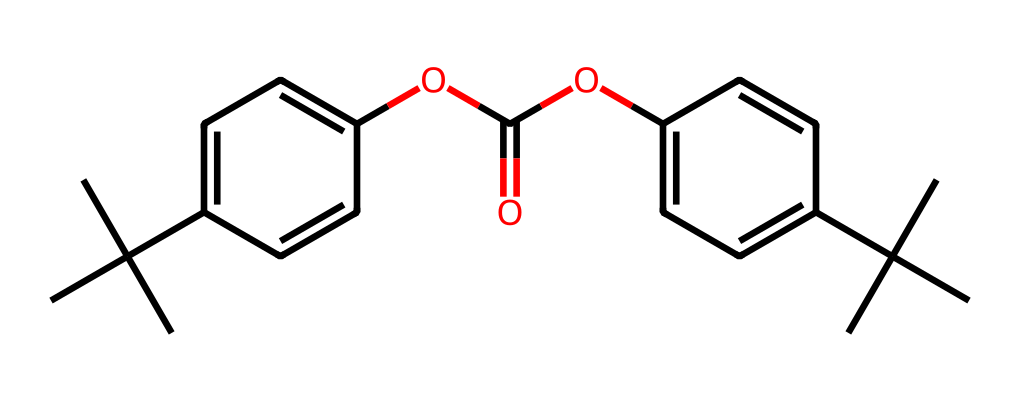How many carbon atoms are present in the molecular structure? By analyzing the SMILES representation, we can count the carbon (C) within the text. Each "C" represents a carbon atom. In this structure, there are various branching and aromatic groups that add up the count of carbon atoms distinctly. Counting all the indicated carbons gives a total of 22 carbon atoms.
Answer: 22 What type of functional group is present in this structure? From the SMILES notation, we can identify the ester functional group by noticing the "OC(=O)" section. The carbon atom (C) is double-bonded to an oxygen atom (O), and also bonded to another functional group or structure, indicating it's an ester.
Answer: ester What is the primary application of polycarbonate plastic? Polycarbonate plastic is primarily used in applications where strength, transparency, and impact resistance are required. This includes products like DVDs and Blu-ray discs, where its properties are essential for durability and clarity.
Answer: DVDs and Blu-rays Does this structure indicate any aromatic rings? By examining the molecular structure derived from the SMILES representation, we can identify the presence of the "c" letters, which signify aromatic carbon atoms forming rings. There are two distinct aromatic rings associated with this chemical structure.
Answer: Yes Is this chemical considered a thermoplastic? The structural details of polycarbonate indicate that it can be melted and re-shaped without significant degradation, which aligns with the characteristics of thermoplastics. Therefore, polycarbonate is indeed classified as a thermoplastic.
Answer: Yes 